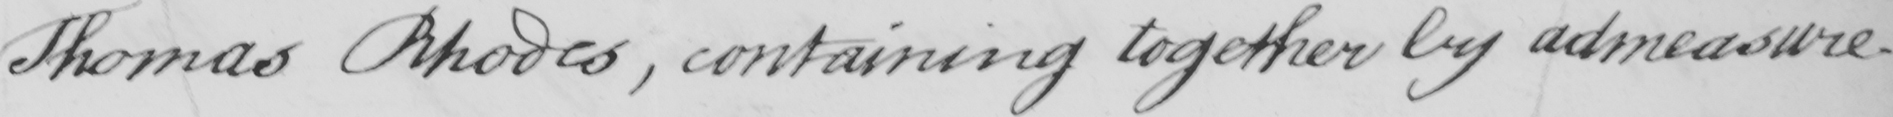What does this handwritten line say? Thomas Rhodes , containing together by admeasure- 